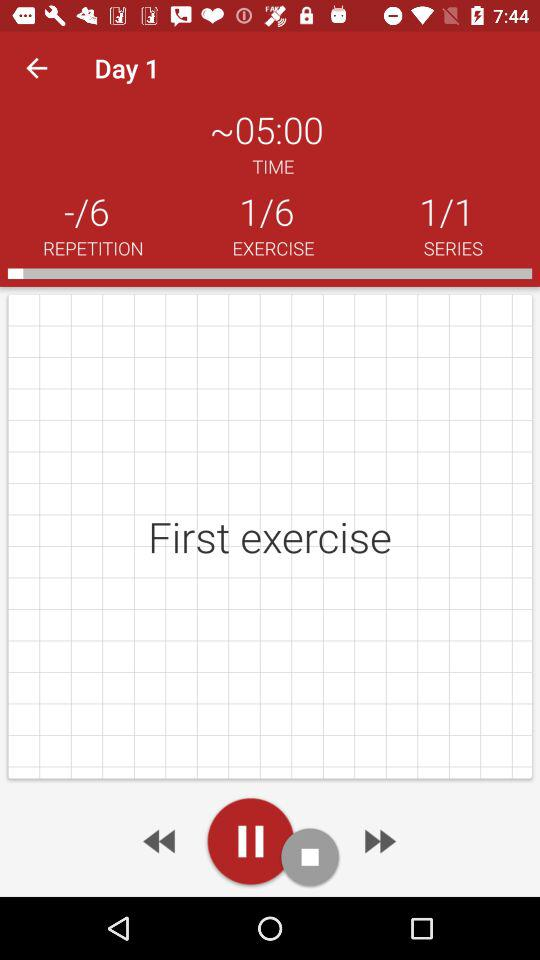How many repetitions are there in the workout?
Answer the question using a single word or phrase. 6 